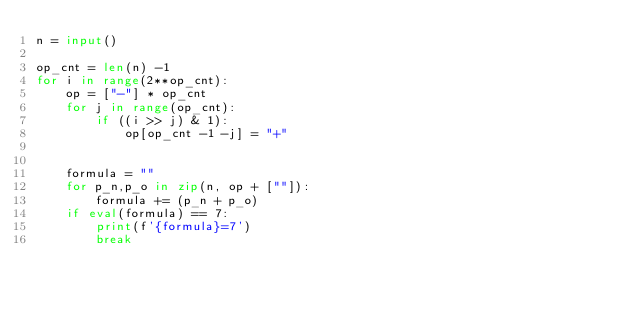Convert code to text. <code><loc_0><loc_0><loc_500><loc_500><_Python_>n = input()

op_cnt = len(n) -1
for i in range(2**op_cnt):
    op = ["-"] * op_cnt
    for j in range(op_cnt):
        if ((i >> j) & 1):
            op[op_cnt -1 -j] = "+"
    
            
    formula = ""
    for p_n,p_o in zip(n, op + [""]):
        formula += (p_n + p_o)
    if eval(formula) == 7:
        print(f'{formula}=7')
        break</code> 